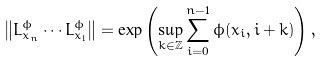<formula> <loc_0><loc_0><loc_500><loc_500>\left \| L _ { x _ { n } } ^ { \phi } \cdots L _ { x _ { 1 } } ^ { \phi } \right \| = \exp \left ( \sup _ { k \in \mathbb { Z } } \sum _ { i = 0 } ^ { n - 1 } \phi ( x _ { i } , i + k ) \right ) ,</formula> 